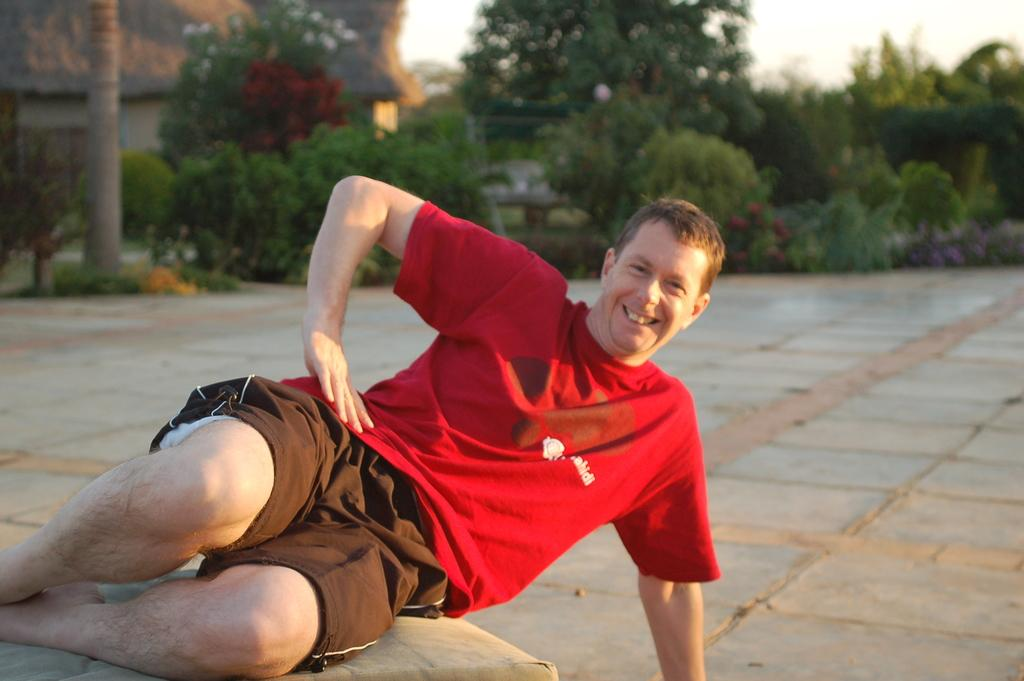What is the person in the image doing? There is a person sitting on a coach in the image. What can be seen behind the person? There are trees behind the person. What type of vegetation is present on the grassland in the image? There are plants on the grassland in the image. What is visible at the top of the image? The sky is visible at the top of the image. What object is located on the left side of the image? There is a tree trunk on the left side of the image. What type of hair is the person in the image wearing? The image does not show the person's hair, so it cannot be determined from the image. 